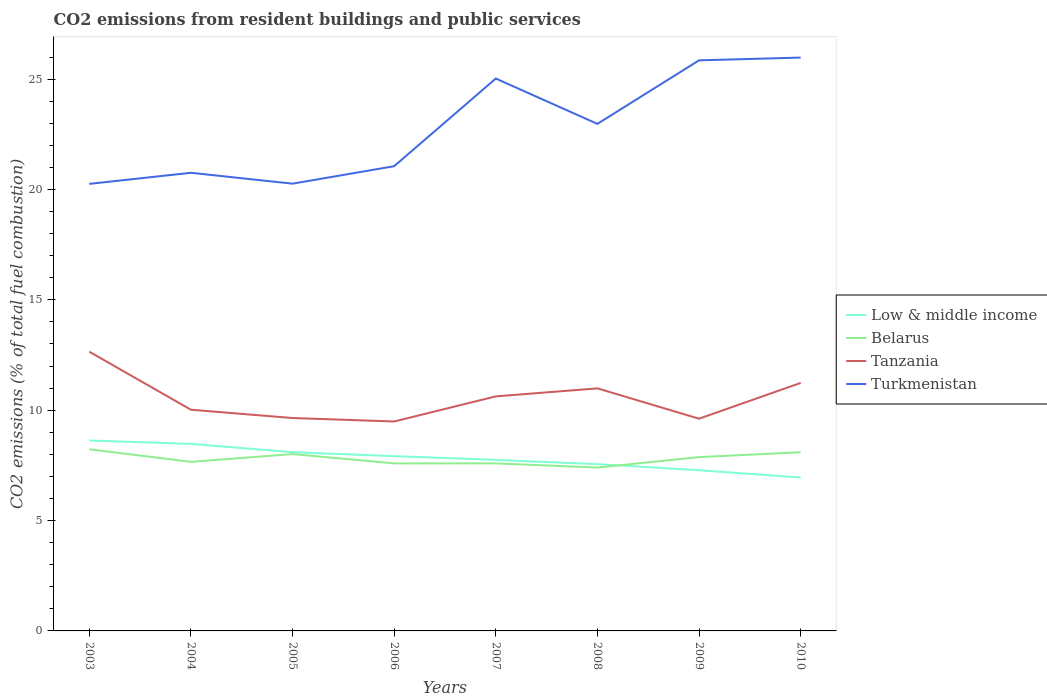Across all years, what is the maximum total CO2 emitted in Tanzania?
Offer a terse response. 9.49. In which year was the total CO2 emitted in Tanzania maximum?
Keep it short and to the point. 2006. What is the total total CO2 emitted in Low & middle income in the graph?
Ensure brevity in your answer.  0.54. What is the difference between the highest and the second highest total CO2 emitted in Low & middle income?
Provide a succinct answer. 1.68. What is the difference between the highest and the lowest total CO2 emitted in Belarus?
Provide a short and direct response. 4. What is the difference between two consecutive major ticks on the Y-axis?
Your answer should be very brief. 5. Are the values on the major ticks of Y-axis written in scientific E-notation?
Give a very brief answer. No. What is the title of the graph?
Keep it short and to the point. CO2 emissions from resident buildings and public services. What is the label or title of the X-axis?
Your answer should be very brief. Years. What is the label or title of the Y-axis?
Make the answer very short. CO2 emissions (% of total fuel combustion). What is the CO2 emissions (% of total fuel combustion) in Low & middle income in 2003?
Provide a short and direct response. 8.63. What is the CO2 emissions (% of total fuel combustion) of Belarus in 2003?
Provide a succinct answer. 8.23. What is the CO2 emissions (% of total fuel combustion) in Tanzania in 2003?
Your response must be concise. 12.65. What is the CO2 emissions (% of total fuel combustion) of Turkmenistan in 2003?
Ensure brevity in your answer.  20.25. What is the CO2 emissions (% of total fuel combustion) in Low & middle income in 2004?
Provide a short and direct response. 8.47. What is the CO2 emissions (% of total fuel combustion) in Belarus in 2004?
Ensure brevity in your answer.  7.66. What is the CO2 emissions (% of total fuel combustion) in Tanzania in 2004?
Your answer should be very brief. 10.02. What is the CO2 emissions (% of total fuel combustion) in Turkmenistan in 2004?
Keep it short and to the point. 20.76. What is the CO2 emissions (% of total fuel combustion) of Low & middle income in 2005?
Your response must be concise. 8.1. What is the CO2 emissions (% of total fuel combustion) in Belarus in 2005?
Provide a short and direct response. 8.01. What is the CO2 emissions (% of total fuel combustion) of Tanzania in 2005?
Your response must be concise. 9.65. What is the CO2 emissions (% of total fuel combustion) in Turkmenistan in 2005?
Provide a succinct answer. 20.26. What is the CO2 emissions (% of total fuel combustion) in Low & middle income in 2006?
Your response must be concise. 7.92. What is the CO2 emissions (% of total fuel combustion) of Belarus in 2006?
Keep it short and to the point. 7.59. What is the CO2 emissions (% of total fuel combustion) of Tanzania in 2006?
Offer a very short reply. 9.49. What is the CO2 emissions (% of total fuel combustion) of Turkmenistan in 2006?
Make the answer very short. 21.05. What is the CO2 emissions (% of total fuel combustion) of Low & middle income in 2007?
Offer a terse response. 7.75. What is the CO2 emissions (% of total fuel combustion) in Belarus in 2007?
Your answer should be very brief. 7.59. What is the CO2 emissions (% of total fuel combustion) of Tanzania in 2007?
Your answer should be compact. 10.63. What is the CO2 emissions (% of total fuel combustion) in Turkmenistan in 2007?
Your answer should be compact. 25.03. What is the CO2 emissions (% of total fuel combustion) of Low & middle income in 2008?
Your response must be concise. 7.56. What is the CO2 emissions (% of total fuel combustion) in Belarus in 2008?
Provide a succinct answer. 7.4. What is the CO2 emissions (% of total fuel combustion) of Tanzania in 2008?
Your answer should be very brief. 10.99. What is the CO2 emissions (% of total fuel combustion) of Turkmenistan in 2008?
Offer a very short reply. 22.97. What is the CO2 emissions (% of total fuel combustion) in Low & middle income in 2009?
Offer a very short reply. 7.28. What is the CO2 emissions (% of total fuel combustion) of Belarus in 2009?
Provide a short and direct response. 7.88. What is the CO2 emissions (% of total fuel combustion) in Tanzania in 2009?
Your response must be concise. 9.62. What is the CO2 emissions (% of total fuel combustion) of Turkmenistan in 2009?
Keep it short and to the point. 25.85. What is the CO2 emissions (% of total fuel combustion) of Low & middle income in 2010?
Give a very brief answer. 6.95. What is the CO2 emissions (% of total fuel combustion) of Belarus in 2010?
Offer a very short reply. 8.1. What is the CO2 emissions (% of total fuel combustion) of Tanzania in 2010?
Your answer should be compact. 11.24. What is the CO2 emissions (% of total fuel combustion) of Turkmenistan in 2010?
Keep it short and to the point. 25.98. Across all years, what is the maximum CO2 emissions (% of total fuel combustion) of Low & middle income?
Your answer should be very brief. 8.63. Across all years, what is the maximum CO2 emissions (% of total fuel combustion) in Belarus?
Ensure brevity in your answer.  8.23. Across all years, what is the maximum CO2 emissions (% of total fuel combustion) in Tanzania?
Provide a short and direct response. 12.65. Across all years, what is the maximum CO2 emissions (% of total fuel combustion) in Turkmenistan?
Ensure brevity in your answer.  25.98. Across all years, what is the minimum CO2 emissions (% of total fuel combustion) of Low & middle income?
Provide a succinct answer. 6.95. Across all years, what is the minimum CO2 emissions (% of total fuel combustion) of Belarus?
Provide a succinct answer. 7.4. Across all years, what is the minimum CO2 emissions (% of total fuel combustion) of Tanzania?
Offer a very short reply. 9.49. Across all years, what is the minimum CO2 emissions (% of total fuel combustion) of Turkmenistan?
Your response must be concise. 20.25. What is the total CO2 emissions (% of total fuel combustion) in Low & middle income in the graph?
Provide a short and direct response. 62.65. What is the total CO2 emissions (% of total fuel combustion) of Belarus in the graph?
Your answer should be very brief. 62.46. What is the total CO2 emissions (% of total fuel combustion) of Tanzania in the graph?
Provide a short and direct response. 84.27. What is the total CO2 emissions (% of total fuel combustion) in Turkmenistan in the graph?
Offer a very short reply. 182.16. What is the difference between the CO2 emissions (% of total fuel combustion) in Low & middle income in 2003 and that in 2004?
Make the answer very short. 0.15. What is the difference between the CO2 emissions (% of total fuel combustion) of Belarus in 2003 and that in 2004?
Offer a terse response. 0.57. What is the difference between the CO2 emissions (% of total fuel combustion) of Tanzania in 2003 and that in 2004?
Keep it short and to the point. 2.63. What is the difference between the CO2 emissions (% of total fuel combustion) in Turkmenistan in 2003 and that in 2004?
Keep it short and to the point. -0.5. What is the difference between the CO2 emissions (% of total fuel combustion) in Low & middle income in 2003 and that in 2005?
Your answer should be very brief. 0.53. What is the difference between the CO2 emissions (% of total fuel combustion) of Belarus in 2003 and that in 2005?
Offer a very short reply. 0.22. What is the difference between the CO2 emissions (% of total fuel combustion) of Tanzania in 2003 and that in 2005?
Offer a terse response. 3. What is the difference between the CO2 emissions (% of total fuel combustion) of Turkmenistan in 2003 and that in 2005?
Offer a terse response. -0.01. What is the difference between the CO2 emissions (% of total fuel combustion) of Low & middle income in 2003 and that in 2006?
Keep it short and to the point. 0.71. What is the difference between the CO2 emissions (% of total fuel combustion) of Belarus in 2003 and that in 2006?
Ensure brevity in your answer.  0.64. What is the difference between the CO2 emissions (% of total fuel combustion) in Tanzania in 2003 and that in 2006?
Provide a short and direct response. 3.16. What is the difference between the CO2 emissions (% of total fuel combustion) in Turkmenistan in 2003 and that in 2006?
Your response must be concise. -0.8. What is the difference between the CO2 emissions (% of total fuel combustion) of Low & middle income in 2003 and that in 2007?
Make the answer very short. 0.88. What is the difference between the CO2 emissions (% of total fuel combustion) of Belarus in 2003 and that in 2007?
Your response must be concise. 0.64. What is the difference between the CO2 emissions (% of total fuel combustion) of Tanzania in 2003 and that in 2007?
Ensure brevity in your answer.  2.02. What is the difference between the CO2 emissions (% of total fuel combustion) in Turkmenistan in 2003 and that in 2007?
Keep it short and to the point. -4.77. What is the difference between the CO2 emissions (% of total fuel combustion) in Low & middle income in 2003 and that in 2008?
Your answer should be compact. 1.07. What is the difference between the CO2 emissions (% of total fuel combustion) in Belarus in 2003 and that in 2008?
Provide a succinct answer. 0.83. What is the difference between the CO2 emissions (% of total fuel combustion) in Tanzania in 2003 and that in 2008?
Keep it short and to the point. 1.66. What is the difference between the CO2 emissions (% of total fuel combustion) of Turkmenistan in 2003 and that in 2008?
Your response must be concise. -2.72. What is the difference between the CO2 emissions (% of total fuel combustion) in Low & middle income in 2003 and that in 2009?
Provide a short and direct response. 1.35. What is the difference between the CO2 emissions (% of total fuel combustion) of Belarus in 2003 and that in 2009?
Your response must be concise. 0.35. What is the difference between the CO2 emissions (% of total fuel combustion) in Tanzania in 2003 and that in 2009?
Offer a terse response. 3.04. What is the difference between the CO2 emissions (% of total fuel combustion) of Turkmenistan in 2003 and that in 2009?
Give a very brief answer. -5.6. What is the difference between the CO2 emissions (% of total fuel combustion) in Low & middle income in 2003 and that in 2010?
Offer a very short reply. 1.68. What is the difference between the CO2 emissions (% of total fuel combustion) in Belarus in 2003 and that in 2010?
Offer a terse response. 0.13. What is the difference between the CO2 emissions (% of total fuel combustion) in Tanzania in 2003 and that in 2010?
Give a very brief answer. 1.41. What is the difference between the CO2 emissions (% of total fuel combustion) in Turkmenistan in 2003 and that in 2010?
Give a very brief answer. -5.72. What is the difference between the CO2 emissions (% of total fuel combustion) in Low & middle income in 2004 and that in 2005?
Give a very brief answer. 0.38. What is the difference between the CO2 emissions (% of total fuel combustion) of Belarus in 2004 and that in 2005?
Ensure brevity in your answer.  -0.35. What is the difference between the CO2 emissions (% of total fuel combustion) of Tanzania in 2004 and that in 2005?
Ensure brevity in your answer.  0.38. What is the difference between the CO2 emissions (% of total fuel combustion) in Turkmenistan in 2004 and that in 2005?
Give a very brief answer. 0.49. What is the difference between the CO2 emissions (% of total fuel combustion) in Low & middle income in 2004 and that in 2006?
Make the answer very short. 0.56. What is the difference between the CO2 emissions (% of total fuel combustion) of Belarus in 2004 and that in 2006?
Offer a terse response. 0.07. What is the difference between the CO2 emissions (% of total fuel combustion) in Tanzania in 2004 and that in 2006?
Give a very brief answer. 0.53. What is the difference between the CO2 emissions (% of total fuel combustion) in Turkmenistan in 2004 and that in 2006?
Make the answer very short. -0.3. What is the difference between the CO2 emissions (% of total fuel combustion) in Low & middle income in 2004 and that in 2007?
Keep it short and to the point. 0.72. What is the difference between the CO2 emissions (% of total fuel combustion) in Belarus in 2004 and that in 2007?
Give a very brief answer. 0.07. What is the difference between the CO2 emissions (% of total fuel combustion) in Tanzania in 2004 and that in 2007?
Your answer should be very brief. -0.6. What is the difference between the CO2 emissions (% of total fuel combustion) of Turkmenistan in 2004 and that in 2007?
Provide a succinct answer. -4.27. What is the difference between the CO2 emissions (% of total fuel combustion) in Low & middle income in 2004 and that in 2008?
Offer a very short reply. 0.92. What is the difference between the CO2 emissions (% of total fuel combustion) of Belarus in 2004 and that in 2008?
Offer a very short reply. 0.26. What is the difference between the CO2 emissions (% of total fuel combustion) in Tanzania in 2004 and that in 2008?
Offer a terse response. -0.97. What is the difference between the CO2 emissions (% of total fuel combustion) of Turkmenistan in 2004 and that in 2008?
Offer a terse response. -2.22. What is the difference between the CO2 emissions (% of total fuel combustion) in Low & middle income in 2004 and that in 2009?
Your response must be concise. 1.19. What is the difference between the CO2 emissions (% of total fuel combustion) of Belarus in 2004 and that in 2009?
Keep it short and to the point. -0.21. What is the difference between the CO2 emissions (% of total fuel combustion) in Tanzania in 2004 and that in 2009?
Provide a succinct answer. 0.41. What is the difference between the CO2 emissions (% of total fuel combustion) in Turkmenistan in 2004 and that in 2009?
Provide a short and direct response. -5.09. What is the difference between the CO2 emissions (% of total fuel combustion) of Low & middle income in 2004 and that in 2010?
Your answer should be compact. 1.52. What is the difference between the CO2 emissions (% of total fuel combustion) in Belarus in 2004 and that in 2010?
Provide a short and direct response. -0.44. What is the difference between the CO2 emissions (% of total fuel combustion) of Tanzania in 2004 and that in 2010?
Offer a very short reply. -1.21. What is the difference between the CO2 emissions (% of total fuel combustion) in Turkmenistan in 2004 and that in 2010?
Your response must be concise. -5.22. What is the difference between the CO2 emissions (% of total fuel combustion) of Low & middle income in 2005 and that in 2006?
Your response must be concise. 0.18. What is the difference between the CO2 emissions (% of total fuel combustion) in Belarus in 2005 and that in 2006?
Your answer should be very brief. 0.42. What is the difference between the CO2 emissions (% of total fuel combustion) in Tanzania in 2005 and that in 2006?
Keep it short and to the point. 0.16. What is the difference between the CO2 emissions (% of total fuel combustion) in Turkmenistan in 2005 and that in 2006?
Make the answer very short. -0.79. What is the difference between the CO2 emissions (% of total fuel combustion) in Low & middle income in 2005 and that in 2007?
Offer a terse response. 0.35. What is the difference between the CO2 emissions (% of total fuel combustion) of Belarus in 2005 and that in 2007?
Your answer should be compact. 0.42. What is the difference between the CO2 emissions (% of total fuel combustion) in Tanzania in 2005 and that in 2007?
Keep it short and to the point. -0.98. What is the difference between the CO2 emissions (% of total fuel combustion) in Turkmenistan in 2005 and that in 2007?
Your answer should be compact. -4.76. What is the difference between the CO2 emissions (% of total fuel combustion) in Low & middle income in 2005 and that in 2008?
Provide a succinct answer. 0.54. What is the difference between the CO2 emissions (% of total fuel combustion) of Belarus in 2005 and that in 2008?
Keep it short and to the point. 0.61. What is the difference between the CO2 emissions (% of total fuel combustion) of Tanzania in 2005 and that in 2008?
Provide a succinct answer. -1.34. What is the difference between the CO2 emissions (% of total fuel combustion) of Turkmenistan in 2005 and that in 2008?
Keep it short and to the point. -2.71. What is the difference between the CO2 emissions (% of total fuel combustion) in Low & middle income in 2005 and that in 2009?
Keep it short and to the point. 0.82. What is the difference between the CO2 emissions (% of total fuel combustion) in Belarus in 2005 and that in 2009?
Give a very brief answer. 0.14. What is the difference between the CO2 emissions (% of total fuel combustion) of Tanzania in 2005 and that in 2009?
Offer a terse response. 0.03. What is the difference between the CO2 emissions (% of total fuel combustion) of Turkmenistan in 2005 and that in 2009?
Give a very brief answer. -5.59. What is the difference between the CO2 emissions (% of total fuel combustion) in Low & middle income in 2005 and that in 2010?
Make the answer very short. 1.15. What is the difference between the CO2 emissions (% of total fuel combustion) of Belarus in 2005 and that in 2010?
Provide a short and direct response. -0.08. What is the difference between the CO2 emissions (% of total fuel combustion) in Tanzania in 2005 and that in 2010?
Your response must be concise. -1.59. What is the difference between the CO2 emissions (% of total fuel combustion) of Turkmenistan in 2005 and that in 2010?
Your answer should be compact. -5.71. What is the difference between the CO2 emissions (% of total fuel combustion) in Low & middle income in 2006 and that in 2007?
Give a very brief answer. 0.17. What is the difference between the CO2 emissions (% of total fuel combustion) of Belarus in 2006 and that in 2007?
Give a very brief answer. -0. What is the difference between the CO2 emissions (% of total fuel combustion) in Tanzania in 2006 and that in 2007?
Ensure brevity in your answer.  -1.14. What is the difference between the CO2 emissions (% of total fuel combustion) of Turkmenistan in 2006 and that in 2007?
Your answer should be compact. -3.97. What is the difference between the CO2 emissions (% of total fuel combustion) in Low & middle income in 2006 and that in 2008?
Offer a very short reply. 0.36. What is the difference between the CO2 emissions (% of total fuel combustion) of Belarus in 2006 and that in 2008?
Provide a succinct answer. 0.19. What is the difference between the CO2 emissions (% of total fuel combustion) in Turkmenistan in 2006 and that in 2008?
Your answer should be compact. -1.92. What is the difference between the CO2 emissions (% of total fuel combustion) of Low & middle income in 2006 and that in 2009?
Your answer should be very brief. 0.64. What is the difference between the CO2 emissions (% of total fuel combustion) in Belarus in 2006 and that in 2009?
Offer a very short reply. -0.28. What is the difference between the CO2 emissions (% of total fuel combustion) in Tanzania in 2006 and that in 2009?
Your answer should be compact. -0.13. What is the difference between the CO2 emissions (% of total fuel combustion) of Turkmenistan in 2006 and that in 2009?
Offer a very short reply. -4.8. What is the difference between the CO2 emissions (% of total fuel combustion) of Low & middle income in 2006 and that in 2010?
Make the answer very short. 0.97. What is the difference between the CO2 emissions (% of total fuel combustion) in Belarus in 2006 and that in 2010?
Offer a very short reply. -0.51. What is the difference between the CO2 emissions (% of total fuel combustion) in Tanzania in 2006 and that in 2010?
Your response must be concise. -1.75. What is the difference between the CO2 emissions (% of total fuel combustion) of Turkmenistan in 2006 and that in 2010?
Your response must be concise. -4.92. What is the difference between the CO2 emissions (% of total fuel combustion) in Low & middle income in 2007 and that in 2008?
Make the answer very short. 0.2. What is the difference between the CO2 emissions (% of total fuel combustion) in Belarus in 2007 and that in 2008?
Ensure brevity in your answer.  0.19. What is the difference between the CO2 emissions (% of total fuel combustion) in Tanzania in 2007 and that in 2008?
Your answer should be very brief. -0.36. What is the difference between the CO2 emissions (% of total fuel combustion) in Turkmenistan in 2007 and that in 2008?
Offer a terse response. 2.05. What is the difference between the CO2 emissions (% of total fuel combustion) in Low & middle income in 2007 and that in 2009?
Provide a succinct answer. 0.47. What is the difference between the CO2 emissions (% of total fuel combustion) in Belarus in 2007 and that in 2009?
Your answer should be compact. -0.28. What is the difference between the CO2 emissions (% of total fuel combustion) in Tanzania in 2007 and that in 2009?
Ensure brevity in your answer.  1.01. What is the difference between the CO2 emissions (% of total fuel combustion) in Turkmenistan in 2007 and that in 2009?
Keep it short and to the point. -0.82. What is the difference between the CO2 emissions (% of total fuel combustion) in Low & middle income in 2007 and that in 2010?
Your answer should be compact. 0.8. What is the difference between the CO2 emissions (% of total fuel combustion) of Belarus in 2007 and that in 2010?
Make the answer very short. -0.51. What is the difference between the CO2 emissions (% of total fuel combustion) in Tanzania in 2007 and that in 2010?
Offer a very short reply. -0.61. What is the difference between the CO2 emissions (% of total fuel combustion) of Turkmenistan in 2007 and that in 2010?
Keep it short and to the point. -0.95. What is the difference between the CO2 emissions (% of total fuel combustion) of Low & middle income in 2008 and that in 2009?
Your answer should be compact. 0.28. What is the difference between the CO2 emissions (% of total fuel combustion) of Belarus in 2008 and that in 2009?
Offer a terse response. -0.47. What is the difference between the CO2 emissions (% of total fuel combustion) in Tanzania in 2008 and that in 2009?
Your response must be concise. 1.37. What is the difference between the CO2 emissions (% of total fuel combustion) in Turkmenistan in 2008 and that in 2009?
Offer a terse response. -2.88. What is the difference between the CO2 emissions (% of total fuel combustion) in Low & middle income in 2008 and that in 2010?
Provide a succinct answer. 0.6. What is the difference between the CO2 emissions (% of total fuel combustion) of Belarus in 2008 and that in 2010?
Provide a succinct answer. -0.69. What is the difference between the CO2 emissions (% of total fuel combustion) in Tanzania in 2008 and that in 2010?
Keep it short and to the point. -0.25. What is the difference between the CO2 emissions (% of total fuel combustion) in Turkmenistan in 2008 and that in 2010?
Offer a very short reply. -3. What is the difference between the CO2 emissions (% of total fuel combustion) in Low & middle income in 2009 and that in 2010?
Make the answer very short. 0.33. What is the difference between the CO2 emissions (% of total fuel combustion) of Belarus in 2009 and that in 2010?
Provide a short and direct response. -0.22. What is the difference between the CO2 emissions (% of total fuel combustion) of Tanzania in 2009 and that in 2010?
Ensure brevity in your answer.  -1.62. What is the difference between the CO2 emissions (% of total fuel combustion) in Turkmenistan in 2009 and that in 2010?
Your answer should be compact. -0.13. What is the difference between the CO2 emissions (% of total fuel combustion) of Low & middle income in 2003 and the CO2 emissions (% of total fuel combustion) of Belarus in 2004?
Keep it short and to the point. 0.97. What is the difference between the CO2 emissions (% of total fuel combustion) in Low & middle income in 2003 and the CO2 emissions (% of total fuel combustion) in Tanzania in 2004?
Ensure brevity in your answer.  -1.39. What is the difference between the CO2 emissions (% of total fuel combustion) in Low & middle income in 2003 and the CO2 emissions (% of total fuel combustion) in Turkmenistan in 2004?
Make the answer very short. -12.13. What is the difference between the CO2 emissions (% of total fuel combustion) of Belarus in 2003 and the CO2 emissions (% of total fuel combustion) of Tanzania in 2004?
Your answer should be compact. -1.79. What is the difference between the CO2 emissions (% of total fuel combustion) of Belarus in 2003 and the CO2 emissions (% of total fuel combustion) of Turkmenistan in 2004?
Ensure brevity in your answer.  -12.53. What is the difference between the CO2 emissions (% of total fuel combustion) of Tanzania in 2003 and the CO2 emissions (% of total fuel combustion) of Turkmenistan in 2004?
Your response must be concise. -8.11. What is the difference between the CO2 emissions (% of total fuel combustion) in Low & middle income in 2003 and the CO2 emissions (% of total fuel combustion) in Belarus in 2005?
Provide a short and direct response. 0.62. What is the difference between the CO2 emissions (% of total fuel combustion) in Low & middle income in 2003 and the CO2 emissions (% of total fuel combustion) in Tanzania in 2005?
Your answer should be compact. -1.02. What is the difference between the CO2 emissions (% of total fuel combustion) of Low & middle income in 2003 and the CO2 emissions (% of total fuel combustion) of Turkmenistan in 2005?
Your answer should be compact. -11.64. What is the difference between the CO2 emissions (% of total fuel combustion) of Belarus in 2003 and the CO2 emissions (% of total fuel combustion) of Tanzania in 2005?
Your answer should be very brief. -1.42. What is the difference between the CO2 emissions (% of total fuel combustion) in Belarus in 2003 and the CO2 emissions (% of total fuel combustion) in Turkmenistan in 2005?
Provide a succinct answer. -12.03. What is the difference between the CO2 emissions (% of total fuel combustion) in Tanzania in 2003 and the CO2 emissions (% of total fuel combustion) in Turkmenistan in 2005?
Make the answer very short. -7.61. What is the difference between the CO2 emissions (% of total fuel combustion) in Low & middle income in 2003 and the CO2 emissions (% of total fuel combustion) in Belarus in 2006?
Give a very brief answer. 1.04. What is the difference between the CO2 emissions (% of total fuel combustion) of Low & middle income in 2003 and the CO2 emissions (% of total fuel combustion) of Tanzania in 2006?
Your answer should be very brief. -0.86. What is the difference between the CO2 emissions (% of total fuel combustion) in Low & middle income in 2003 and the CO2 emissions (% of total fuel combustion) in Turkmenistan in 2006?
Your response must be concise. -12.43. What is the difference between the CO2 emissions (% of total fuel combustion) in Belarus in 2003 and the CO2 emissions (% of total fuel combustion) in Tanzania in 2006?
Provide a short and direct response. -1.26. What is the difference between the CO2 emissions (% of total fuel combustion) in Belarus in 2003 and the CO2 emissions (% of total fuel combustion) in Turkmenistan in 2006?
Your response must be concise. -12.82. What is the difference between the CO2 emissions (% of total fuel combustion) of Tanzania in 2003 and the CO2 emissions (% of total fuel combustion) of Turkmenistan in 2006?
Offer a very short reply. -8.4. What is the difference between the CO2 emissions (% of total fuel combustion) of Low & middle income in 2003 and the CO2 emissions (% of total fuel combustion) of Belarus in 2007?
Provide a succinct answer. 1.04. What is the difference between the CO2 emissions (% of total fuel combustion) of Low & middle income in 2003 and the CO2 emissions (% of total fuel combustion) of Tanzania in 2007?
Keep it short and to the point. -2. What is the difference between the CO2 emissions (% of total fuel combustion) in Low & middle income in 2003 and the CO2 emissions (% of total fuel combustion) in Turkmenistan in 2007?
Your answer should be compact. -16.4. What is the difference between the CO2 emissions (% of total fuel combustion) in Belarus in 2003 and the CO2 emissions (% of total fuel combustion) in Tanzania in 2007?
Your response must be concise. -2.4. What is the difference between the CO2 emissions (% of total fuel combustion) of Belarus in 2003 and the CO2 emissions (% of total fuel combustion) of Turkmenistan in 2007?
Provide a succinct answer. -16.8. What is the difference between the CO2 emissions (% of total fuel combustion) of Tanzania in 2003 and the CO2 emissions (% of total fuel combustion) of Turkmenistan in 2007?
Your answer should be very brief. -12.38. What is the difference between the CO2 emissions (% of total fuel combustion) in Low & middle income in 2003 and the CO2 emissions (% of total fuel combustion) in Belarus in 2008?
Give a very brief answer. 1.23. What is the difference between the CO2 emissions (% of total fuel combustion) in Low & middle income in 2003 and the CO2 emissions (% of total fuel combustion) in Tanzania in 2008?
Provide a short and direct response. -2.36. What is the difference between the CO2 emissions (% of total fuel combustion) of Low & middle income in 2003 and the CO2 emissions (% of total fuel combustion) of Turkmenistan in 2008?
Provide a short and direct response. -14.34. What is the difference between the CO2 emissions (% of total fuel combustion) in Belarus in 2003 and the CO2 emissions (% of total fuel combustion) in Tanzania in 2008?
Offer a terse response. -2.76. What is the difference between the CO2 emissions (% of total fuel combustion) in Belarus in 2003 and the CO2 emissions (% of total fuel combustion) in Turkmenistan in 2008?
Give a very brief answer. -14.74. What is the difference between the CO2 emissions (% of total fuel combustion) in Tanzania in 2003 and the CO2 emissions (% of total fuel combustion) in Turkmenistan in 2008?
Provide a short and direct response. -10.32. What is the difference between the CO2 emissions (% of total fuel combustion) in Low & middle income in 2003 and the CO2 emissions (% of total fuel combustion) in Belarus in 2009?
Make the answer very short. 0.75. What is the difference between the CO2 emissions (% of total fuel combustion) in Low & middle income in 2003 and the CO2 emissions (% of total fuel combustion) in Tanzania in 2009?
Your response must be concise. -0.99. What is the difference between the CO2 emissions (% of total fuel combustion) of Low & middle income in 2003 and the CO2 emissions (% of total fuel combustion) of Turkmenistan in 2009?
Provide a short and direct response. -17.22. What is the difference between the CO2 emissions (% of total fuel combustion) in Belarus in 2003 and the CO2 emissions (% of total fuel combustion) in Tanzania in 2009?
Make the answer very short. -1.39. What is the difference between the CO2 emissions (% of total fuel combustion) in Belarus in 2003 and the CO2 emissions (% of total fuel combustion) in Turkmenistan in 2009?
Provide a short and direct response. -17.62. What is the difference between the CO2 emissions (% of total fuel combustion) of Tanzania in 2003 and the CO2 emissions (% of total fuel combustion) of Turkmenistan in 2009?
Provide a short and direct response. -13.2. What is the difference between the CO2 emissions (% of total fuel combustion) of Low & middle income in 2003 and the CO2 emissions (% of total fuel combustion) of Belarus in 2010?
Ensure brevity in your answer.  0.53. What is the difference between the CO2 emissions (% of total fuel combustion) of Low & middle income in 2003 and the CO2 emissions (% of total fuel combustion) of Tanzania in 2010?
Your answer should be very brief. -2.61. What is the difference between the CO2 emissions (% of total fuel combustion) of Low & middle income in 2003 and the CO2 emissions (% of total fuel combustion) of Turkmenistan in 2010?
Offer a very short reply. -17.35. What is the difference between the CO2 emissions (% of total fuel combustion) of Belarus in 2003 and the CO2 emissions (% of total fuel combustion) of Tanzania in 2010?
Provide a short and direct response. -3.01. What is the difference between the CO2 emissions (% of total fuel combustion) in Belarus in 2003 and the CO2 emissions (% of total fuel combustion) in Turkmenistan in 2010?
Provide a short and direct response. -17.75. What is the difference between the CO2 emissions (% of total fuel combustion) of Tanzania in 2003 and the CO2 emissions (% of total fuel combustion) of Turkmenistan in 2010?
Your response must be concise. -13.33. What is the difference between the CO2 emissions (% of total fuel combustion) in Low & middle income in 2004 and the CO2 emissions (% of total fuel combustion) in Belarus in 2005?
Make the answer very short. 0.46. What is the difference between the CO2 emissions (% of total fuel combustion) in Low & middle income in 2004 and the CO2 emissions (% of total fuel combustion) in Tanzania in 2005?
Offer a very short reply. -1.17. What is the difference between the CO2 emissions (% of total fuel combustion) in Low & middle income in 2004 and the CO2 emissions (% of total fuel combustion) in Turkmenistan in 2005?
Give a very brief answer. -11.79. What is the difference between the CO2 emissions (% of total fuel combustion) of Belarus in 2004 and the CO2 emissions (% of total fuel combustion) of Tanzania in 2005?
Your answer should be compact. -1.99. What is the difference between the CO2 emissions (% of total fuel combustion) of Belarus in 2004 and the CO2 emissions (% of total fuel combustion) of Turkmenistan in 2005?
Your response must be concise. -12.6. What is the difference between the CO2 emissions (% of total fuel combustion) in Tanzania in 2004 and the CO2 emissions (% of total fuel combustion) in Turkmenistan in 2005?
Give a very brief answer. -10.24. What is the difference between the CO2 emissions (% of total fuel combustion) in Low & middle income in 2004 and the CO2 emissions (% of total fuel combustion) in Belarus in 2006?
Offer a terse response. 0.88. What is the difference between the CO2 emissions (% of total fuel combustion) of Low & middle income in 2004 and the CO2 emissions (% of total fuel combustion) of Tanzania in 2006?
Your answer should be very brief. -1.02. What is the difference between the CO2 emissions (% of total fuel combustion) in Low & middle income in 2004 and the CO2 emissions (% of total fuel combustion) in Turkmenistan in 2006?
Provide a short and direct response. -12.58. What is the difference between the CO2 emissions (% of total fuel combustion) in Belarus in 2004 and the CO2 emissions (% of total fuel combustion) in Tanzania in 2006?
Make the answer very short. -1.83. What is the difference between the CO2 emissions (% of total fuel combustion) in Belarus in 2004 and the CO2 emissions (% of total fuel combustion) in Turkmenistan in 2006?
Make the answer very short. -13.39. What is the difference between the CO2 emissions (% of total fuel combustion) of Tanzania in 2004 and the CO2 emissions (% of total fuel combustion) of Turkmenistan in 2006?
Your answer should be very brief. -11.03. What is the difference between the CO2 emissions (% of total fuel combustion) in Low & middle income in 2004 and the CO2 emissions (% of total fuel combustion) in Belarus in 2007?
Provide a succinct answer. 0.88. What is the difference between the CO2 emissions (% of total fuel combustion) in Low & middle income in 2004 and the CO2 emissions (% of total fuel combustion) in Tanzania in 2007?
Your answer should be very brief. -2.15. What is the difference between the CO2 emissions (% of total fuel combustion) of Low & middle income in 2004 and the CO2 emissions (% of total fuel combustion) of Turkmenistan in 2007?
Make the answer very short. -16.55. What is the difference between the CO2 emissions (% of total fuel combustion) of Belarus in 2004 and the CO2 emissions (% of total fuel combustion) of Tanzania in 2007?
Provide a short and direct response. -2.97. What is the difference between the CO2 emissions (% of total fuel combustion) of Belarus in 2004 and the CO2 emissions (% of total fuel combustion) of Turkmenistan in 2007?
Ensure brevity in your answer.  -17.37. What is the difference between the CO2 emissions (% of total fuel combustion) in Tanzania in 2004 and the CO2 emissions (% of total fuel combustion) in Turkmenistan in 2007?
Offer a very short reply. -15.01. What is the difference between the CO2 emissions (% of total fuel combustion) in Low & middle income in 2004 and the CO2 emissions (% of total fuel combustion) in Belarus in 2008?
Offer a terse response. 1.07. What is the difference between the CO2 emissions (% of total fuel combustion) in Low & middle income in 2004 and the CO2 emissions (% of total fuel combustion) in Tanzania in 2008?
Your answer should be compact. -2.52. What is the difference between the CO2 emissions (% of total fuel combustion) in Low & middle income in 2004 and the CO2 emissions (% of total fuel combustion) in Turkmenistan in 2008?
Keep it short and to the point. -14.5. What is the difference between the CO2 emissions (% of total fuel combustion) in Belarus in 2004 and the CO2 emissions (% of total fuel combustion) in Tanzania in 2008?
Your answer should be compact. -3.33. What is the difference between the CO2 emissions (% of total fuel combustion) in Belarus in 2004 and the CO2 emissions (% of total fuel combustion) in Turkmenistan in 2008?
Offer a terse response. -15.31. What is the difference between the CO2 emissions (% of total fuel combustion) in Tanzania in 2004 and the CO2 emissions (% of total fuel combustion) in Turkmenistan in 2008?
Your response must be concise. -12.95. What is the difference between the CO2 emissions (% of total fuel combustion) in Low & middle income in 2004 and the CO2 emissions (% of total fuel combustion) in Belarus in 2009?
Offer a very short reply. 0.6. What is the difference between the CO2 emissions (% of total fuel combustion) in Low & middle income in 2004 and the CO2 emissions (% of total fuel combustion) in Tanzania in 2009?
Your response must be concise. -1.14. What is the difference between the CO2 emissions (% of total fuel combustion) in Low & middle income in 2004 and the CO2 emissions (% of total fuel combustion) in Turkmenistan in 2009?
Your answer should be very brief. -17.38. What is the difference between the CO2 emissions (% of total fuel combustion) in Belarus in 2004 and the CO2 emissions (% of total fuel combustion) in Tanzania in 2009?
Offer a terse response. -1.95. What is the difference between the CO2 emissions (% of total fuel combustion) of Belarus in 2004 and the CO2 emissions (% of total fuel combustion) of Turkmenistan in 2009?
Give a very brief answer. -18.19. What is the difference between the CO2 emissions (% of total fuel combustion) in Tanzania in 2004 and the CO2 emissions (% of total fuel combustion) in Turkmenistan in 2009?
Keep it short and to the point. -15.83. What is the difference between the CO2 emissions (% of total fuel combustion) of Low & middle income in 2004 and the CO2 emissions (% of total fuel combustion) of Belarus in 2010?
Keep it short and to the point. 0.38. What is the difference between the CO2 emissions (% of total fuel combustion) in Low & middle income in 2004 and the CO2 emissions (% of total fuel combustion) in Tanzania in 2010?
Provide a succinct answer. -2.76. What is the difference between the CO2 emissions (% of total fuel combustion) in Low & middle income in 2004 and the CO2 emissions (% of total fuel combustion) in Turkmenistan in 2010?
Provide a short and direct response. -17.5. What is the difference between the CO2 emissions (% of total fuel combustion) in Belarus in 2004 and the CO2 emissions (% of total fuel combustion) in Tanzania in 2010?
Your answer should be very brief. -3.58. What is the difference between the CO2 emissions (% of total fuel combustion) in Belarus in 2004 and the CO2 emissions (% of total fuel combustion) in Turkmenistan in 2010?
Make the answer very short. -18.32. What is the difference between the CO2 emissions (% of total fuel combustion) of Tanzania in 2004 and the CO2 emissions (% of total fuel combustion) of Turkmenistan in 2010?
Offer a very short reply. -15.95. What is the difference between the CO2 emissions (% of total fuel combustion) in Low & middle income in 2005 and the CO2 emissions (% of total fuel combustion) in Belarus in 2006?
Your answer should be very brief. 0.51. What is the difference between the CO2 emissions (% of total fuel combustion) of Low & middle income in 2005 and the CO2 emissions (% of total fuel combustion) of Tanzania in 2006?
Provide a short and direct response. -1.39. What is the difference between the CO2 emissions (% of total fuel combustion) of Low & middle income in 2005 and the CO2 emissions (% of total fuel combustion) of Turkmenistan in 2006?
Keep it short and to the point. -12.96. What is the difference between the CO2 emissions (% of total fuel combustion) of Belarus in 2005 and the CO2 emissions (% of total fuel combustion) of Tanzania in 2006?
Your answer should be very brief. -1.48. What is the difference between the CO2 emissions (% of total fuel combustion) of Belarus in 2005 and the CO2 emissions (% of total fuel combustion) of Turkmenistan in 2006?
Make the answer very short. -13.04. What is the difference between the CO2 emissions (% of total fuel combustion) in Tanzania in 2005 and the CO2 emissions (% of total fuel combustion) in Turkmenistan in 2006?
Offer a very short reply. -11.41. What is the difference between the CO2 emissions (% of total fuel combustion) of Low & middle income in 2005 and the CO2 emissions (% of total fuel combustion) of Belarus in 2007?
Your answer should be compact. 0.51. What is the difference between the CO2 emissions (% of total fuel combustion) in Low & middle income in 2005 and the CO2 emissions (% of total fuel combustion) in Tanzania in 2007?
Offer a terse response. -2.53. What is the difference between the CO2 emissions (% of total fuel combustion) in Low & middle income in 2005 and the CO2 emissions (% of total fuel combustion) in Turkmenistan in 2007?
Your answer should be very brief. -16.93. What is the difference between the CO2 emissions (% of total fuel combustion) of Belarus in 2005 and the CO2 emissions (% of total fuel combustion) of Tanzania in 2007?
Your answer should be very brief. -2.61. What is the difference between the CO2 emissions (% of total fuel combustion) in Belarus in 2005 and the CO2 emissions (% of total fuel combustion) in Turkmenistan in 2007?
Keep it short and to the point. -17.01. What is the difference between the CO2 emissions (% of total fuel combustion) of Tanzania in 2005 and the CO2 emissions (% of total fuel combustion) of Turkmenistan in 2007?
Give a very brief answer. -15.38. What is the difference between the CO2 emissions (% of total fuel combustion) in Low & middle income in 2005 and the CO2 emissions (% of total fuel combustion) in Belarus in 2008?
Keep it short and to the point. 0.7. What is the difference between the CO2 emissions (% of total fuel combustion) in Low & middle income in 2005 and the CO2 emissions (% of total fuel combustion) in Tanzania in 2008?
Make the answer very short. -2.89. What is the difference between the CO2 emissions (% of total fuel combustion) in Low & middle income in 2005 and the CO2 emissions (% of total fuel combustion) in Turkmenistan in 2008?
Ensure brevity in your answer.  -14.88. What is the difference between the CO2 emissions (% of total fuel combustion) in Belarus in 2005 and the CO2 emissions (% of total fuel combustion) in Tanzania in 2008?
Make the answer very short. -2.98. What is the difference between the CO2 emissions (% of total fuel combustion) in Belarus in 2005 and the CO2 emissions (% of total fuel combustion) in Turkmenistan in 2008?
Your answer should be compact. -14.96. What is the difference between the CO2 emissions (% of total fuel combustion) in Tanzania in 2005 and the CO2 emissions (% of total fuel combustion) in Turkmenistan in 2008?
Your response must be concise. -13.33. What is the difference between the CO2 emissions (% of total fuel combustion) of Low & middle income in 2005 and the CO2 emissions (% of total fuel combustion) of Belarus in 2009?
Provide a short and direct response. 0.22. What is the difference between the CO2 emissions (% of total fuel combustion) in Low & middle income in 2005 and the CO2 emissions (% of total fuel combustion) in Tanzania in 2009?
Provide a short and direct response. -1.52. What is the difference between the CO2 emissions (% of total fuel combustion) in Low & middle income in 2005 and the CO2 emissions (% of total fuel combustion) in Turkmenistan in 2009?
Provide a succinct answer. -17.75. What is the difference between the CO2 emissions (% of total fuel combustion) of Belarus in 2005 and the CO2 emissions (% of total fuel combustion) of Tanzania in 2009?
Your response must be concise. -1.6. What is the difference between the CO2 emissions (% of total fuel combustion) of Belarus in 2005 and the CO2 emissions (% of total fuel combustion) of Turkmenistan in 2009?
Provide a succinct answer. -17.84. What is the difference between the CO2 emissions (% of total fuel combustion) in Tanzania in 2005 and the CO2 emissions (% of total fuel combustion) in Turkmenistan in 2009?
Make the answer very short. -16.2. What is the difference between the CO2 emissions (% of total fuel combustion) of Low & middle income in 2005 and the CO2 emissions (% of total fuel combustion) of Belarus in 2010?
Give a very brief answer. 0. What is the difference between the CO2 emissions (% of total fuel combustion) of Low & middle income in 2005 and the CO2 emissions (% of total fuel combustion) of Tanzania in 2010?
Offer a very short reply. -3.14. What is the difference between the CO2 emissions (% of total fuel combustion) of Low & middle income in 2005 and the CO2 emissions (% of total fuel combustion) of Turkmenistan in 2010?
Your response must be concise. -17.88. What is the difference between the CO2 emissions (% of total fuel combustion) of Belarus in 2005 and the CO2 emissions (% of total fuel combustion) of Tanzania in 2010?
Make the answer very short. -3.22. What is the difference between the CO2 emissions (% of total fuel combustion) in Belarus in 2005 and the CO2 emissions (% of total fuel combustion) in Turkmenistan in 2010?
Offer a terse response. -17.96. What is the difference between the CO2 emissions (% of total fuel combustion) in Tanzania in 2005 and the CO2 emissions (% of total fuel combustion) in Turkmenistan in 2010?
Offer a terse response. -16.33. What is the difference between the CO2 emissions (% of total fuel combustion) of Low & middle income in 2006 and the CO2 emissions (% of total fuel combustion) of Belarus in 2007?
Ensure brevity in your answer.  0.33. What is the difference between the CO2 emissions (% of total fuel combustion) in Low & middle income in 2006 and the CO2 emissions (% of total fuel combustion) in Tanzania in 2007?
Give a very brief answer. -2.71. What is the difference between the CO2 emissions (% of total fuel combustion) of Low & middle income in 2006 and the CO2 emissions (% of total fuel combustion) of Turkmenistan in 2007?
Your answer should be very brief. -17.11. What is the difference between the CO2 emissions (% of total fuel combustion) of Belarus in 2006 and the CO2 emissions (% of total fuel combustion) of Tanzania in 2007?
Provide a short and direct response. -3.04. What is the difference between the CO2 emissions (% of total fuel combustion) in Belarus in 2006 and the CO2 emissions (% of total fuel combustion) in Turkmenistan in 2007?
Make the answer very short. -17.44. What is the difference between the CO2 emissions (% of total fuel combustion) of Tanzania in 2006 and the CO2 emissions (% of total fuel combustion) of Turkmenistan in 2007?
Your answer should be compact. -15.54. What is the difference between the CO2 emissions (% of total fuel combustion) in Low & middle income in 2006 and the CO2 emissions (% of total fuel combustion) in Belarus in 2008?
Ensure brevity in your answer.  0.52. What is the difference between the CO2 emissions (% of total fuel combustion) in Low & middle income in 2006 and the CO2 emissions (% of total fuel combustion) in Tanzania in 2008?
Make the answer very short. -3.07. What is the difference between the CO2 emissions (% of total fuel combustion) of Low & middle income in 2006 and the CO2 emissions (% of total fuel combustion) of Turkmenistan in 2008?
Offer a very short reply. -15.06. What is the difference between the CO2 emissions (% of total fuel combustion) in Belarus in 2006 and the CO2 emissions (% of total fuel combustion) in Tanzania in 2008?
Provide a succinct answer. -3.4. What is the difference between the CO2 emissions (% of total fuel combustion) in Belarus in 2006 and the CO2 emissions (% of total fuel combustion) in Turkmenistan in 2008?
Provide a succinct answer. -15.38. What is the difference between the CO2 emissions (% of total fuel combustion) of Tanzania in 2006 and the CO2 emissions (% of total fuel combustion) of Turkmenistan in 2008?
Offer a very short reply. -13.48. What is the difference between the CO2 emissions (% of total fuel combustion) in Low & middle income in 2006 and the CO2 emissions (% of total fuel combustion) in Belarus in 2009?
Keep it short and to the point. 0.04. What is the difference between the CO2 emissions (% of total fuel combustion) of Low & middle income in 2006 and the CO2 emissions (% of total fuel combustion) of Tanzania in 2009?
Keep it short and to the point. -1.7. What is the difference between the CO2 emissions (% of total fuel combustion) of Low & middle income in 2006 and the CO2 emissions (% of total fuel combustion) of Turkmenistan in 2009?
Your answer should be very brief. -17.93. What is the difference between the CO2 emissions (% of total fuel combustion) of Belarus in 2006 and the CO2 emissions (% of total fuel combustion) of Tanzania in 2009?
Offer a very short reply. -2.02. What is the difference between the CO2 emissions (% of total fuel combustion) of Belarus in 2006 and the CO2 emissions (% of total fuel combustion) of Turkmenistan in 2009?
Make the answer very short. -18.26. What is the difference between the CO2 emissions (% of total fuel combustion) of Tanzania in 2006 and the CO2 emissions (% of total fuel combustion) of Turkmenistan in 2009?
Provide a short and direct response. -16.36. What is the difference between the CO2 emissions (% of total fuel combustion) in Low & middle income in 2006 and the CO2 emissions (% of total fuel combustion) in Belarus in 2010?
Ensure brevity in your answer.  -0.18. What is the difference between the CO2 emissions (% of total fuel combustion) of Low & middle income in 2006 and the CO2 emissions (% of total fuel combustion) of Tanzania in 2010?
Your answer should be very brief. -3.32. What is the difference between the CO2 emissions (% of total fuel combustion) of Low & middle income in 2006 and the CO2 emissions (% of total fuel combustion) of Turkmenistan in 2010?
Ensure brevity in your answer.  -18.06. What is the difference between the CO2 emissions (% of total fuel combustion) in Belarus in 2006 and the CO2 emissions (% of total fuel combustion) in Tanzania in 2010?
Make the answer very short. -3.65. What is the difference between the CO2 emissions (% of total fuel combustion) of Belarus in 2006 and the CO2 emissions (% of total fuel combustion) of Turkmenistan in 2010?
Ensure brevity in your answer.  -18.39. What is the difference between the CO2 emissions (% of total fuel combustion) in Tanzania in 2006 and the CO2 emissions (% of total fuel combustion) in Turkmenistan in 2010?
Keep it short and to the point. -16.49. What is the difference between the CO2 emissions (% of total fuel combustion) of Low & middle income in 2007 and the CO2 emissions (% of total fuel combustion) of Belarus in 2008?
Your answer should be very brief. 0.35. What is the difference between the CO2 emissions (% of total fuel combustion) in Low & middle income in 2007 and the CO2 emissions (% of total fuel combustion) in Tanzania in 2008?
Your answer should be very brief. -3.24. What is the difference between the CO2 emissions (% of total fuel combustion) of Low & middle income in 2007 and the CO2 emissions (% of total fuel combustion) of Turkmenistan in 2008?
Provide a short and direct response. -15.22. What is the difference between the CO2 emissions (% of total fuel combustion) in Belarus in 2007 and the CO2 emissions (% of total fuel combustion) in Tanzania in 2008?
Ensure brevity in your answer.  -3.4. What is the difference between the CO2 emissions (% of total fuel combustion) of Belarus in 2007 and the CO2 emissions (% of total fuel combustion) of Turkmenistan in 2008?
Offer a terse response. -15.38. What is the difference between the CO2 emissions (% of total fuel combustion) of Tanzania in 2007 and the CO2 emissions (% of total fuel combustion) of Turkmenistan in 2008?
Your response must be concise. -12.35. What is the difference between the CO2 emissions (% of total fuel combustion) in Low & middle income in 2007 and the CO2 emissions (% of total fuel combustion) in Belarus in 2009?
Provide a succinct answer. -0.12. What is the difference between the CO2 emissions (% of total fuel combustion) in Low & middle income in 2007 and the CO2 emissions (% of total fuel combustion) in Tanzania in 2009?
Give a very brief answer. -1.87. What is the difference between the CO2 emissions (% of total fuel combustion) of Low & middle income in 2007 and the CO2 emissions (% of total fuel combustion) of Turkmenistan in 2009?
Offer a terse response. -18.1. What is the difference between the CO2 emissions (% of total fuel combustion) in Belarus in 2007 and the CO2 emissions (% of total fuel combustion) in Tanzania in 2009?
Your response must be concise. -2.02. What is the difference between the CO2 emissions (% of total fuel combustion) of Belarus in 2007 and the CO2 emissions (% of total fuel combustion) of Turkmenistan in 2009?
Your answer should be compact. -18.26. What is the difference between the CO2 emissions (% of total fuel combustion) in Tanzania in 2007 and the CO2 emissions (% of total fuel combustion) in Turkmenistan in 2009?
Ensure brevity in your answer.  -15.22. What is the difference between the CO2 emissions (% of total fuel combustion) of Low & middle income in 2007 and the CO2 emissions (% of total fuel combustion) of Belarus in 2010?
Make the answer very short. -0.35. What is the difference between the CO2 emissions (% of total fuel combustion) of Low & middle income in 2007 and the CO2 emissions (% of total fuel combustion) of Tanzania in 2010?
Your response must be concise. -3.49. What is the difference between the CO2 emissions (% of total fuel combustion) in Low & middle income in 2007 and the CO2 emissions (% of total fuel combustion) in Turkmenistan in 2010?
Your response must be concise. -18.23. What is the difference between the CO2 emissions (% of total fuel combustion) of Belarus in 2007 and the CO2 emissions (% of total fuel combustion) of Tanzania in 2010?
Your answer should be compact. -3.65. What is the difference between the CO2 emissions (% of total fuel combustion) in Belarus in 2007 and the CO2 emissions (% of total fuel combustion) in Turkmenistan in 2010?
Your response must be concise. -18.39. What is the difference between the CO2 emissions (% of total fuel combustion) of Tanzania in 2007 and the CO2 emissions (% of total fuel combustion) of Turkmenistan in 2010?
Offer a very short reply. -15.35. What is the difference between the CO2 emissions (% of total fuel combustion) of Low & middle income in 2008 and the CO2 emissions (% of total fuel combustion) of Belarus in 2009?
Make the answer very short. -0.32. What is the difference between the CO2 emissions (% of total fuel combustion) in Low & middle income in 2008 and the CO2 emissions (% of total fuel combustion) in Tanzania in 2009?
Make the answer very short. -2.06. What is the difference between the CO2 emissions (% of total fuel combustion) in Low & middle income in 2008 and the CO2 emissions (% of total fuel combustion) in Turkmenistan in 2009?
Your answer should be compact. -18.3. What is the difference between the CO2 emissions (% of total fuel combustion) in Belarus in 2008 and the CO2 emissions (% of total fuel combustion) in Tanzania in 2009?
Offer a terse response. -2.21. What is the difference between the CO2 emissions (% of total fuel combustion) in Belarus in 2008 and the CO2 emissions (% of total fuel combustion) in Turkmenistan in 2009?
Ensure brevity in your answer.  -18.45. What is the difference between the CO2 emissions (% of total fuel combustion) of Tanzania in 2008 and the CO2 emissions (% of total fuel combustion) of Turkmenistan in 2009?
Offer a terse response. -14.86. What is the difference between the CO2 emissions (% of total fuel combustion) of Low & middle income in 2008 and the CO2 emissions (% of total fuel combustion) of Belarus in 2010?
Your response must be concise. -0.54. What is the difference between the CO2 emissions (% of total fuel combustion) in Low & middle income in 2008 and the CO2 emissions (% of total fuel combustion) in Tanzania in 2010?
Offer a terse response. -3.68. What is the difference between the CO2 emissions (% of total fuel combustion) in Low & middle income in 2008 and the CO2 emissions (% of total fuel combustion) in Turkmenistan in 2010?
Provide a short and direct response. -18.42. What is the difference between the CO2 emissions (% of total fuel combustion) of Belarus in 2008 and the CO2 emissions (% of total fuel combustion) of Tanzania in 2010?
Keep it short and to the point. -3.83. What is the difference between the CO2 emissions (% of total fuel combustion) in Belarus in 2008 and the CO2 emissions (% of total fuel combustion) in Turkmenistan in 2010?
Keep it short and to the point. -18.57. What is the difference between the CO2 emissions (% of total fuel combustion) in Tanzania in 2008 and the CO2 emissions (% of total fuel combustion) in Turkmenistan in 2010?
Provide a succinct answer. -14.99. What is the difference between the CO2 emissions (% of total fuel combustion) in Low & middle income in 2009 and the CO2 emissions (% of total fuel combustion) in Belarus in 2010?
Keep it short and to the point. -0.82. What is the difference between the CO2 emissions (% of total fuel combustion) of Low & middle income in 2009 and the CO2 emissions (% of total fuel combustion) of Tanzania in 2010?
Your answer should be very brief. -3.96. What is the difference between the CO2 emissions (% of total fuel combustion) in Low & middle income in 2009 and the CO2 emissions (% of total fuel combustion) in Turkmenistan in 2010?
Your answer should be compact. -18.7. What is the difference between the CO2 emissions (% of total fuel combustion) of Belarus in 2009 and the CO2 emissions (% of total fuel combustion) of Tanzania in 2010?
Your response must be concise. -3.36. What is the difference between the CO2 emissions (% of total fuel combustion) of Belarus in 2009 and the CO2 emissions (% of total fuel combustion) of Turkmenistan in 2010?
Your answer should be very brief. -18.1. What is the difference between the CO2 emissions (% of total fuel combustion) in Tanzania in 2009 and the CO2 emissions (% of total fuel combustion) in Turkmenistan in 2010?
Ensure brevity in your answer.  -16.36. What is the average CO2 emissions (% of total fuel combustion) in Low & middle income per year?
Provide a succinct answer. 7.83. What is the average CO2 emissions (% of total fuel combustion) of Belarus per year?
Give a very brief answer. 7.81. What is the average CO2 emissions (% of total fuel combustion) in Tanzania per year?
Offer a terse response. 10.53. What is the average CO2 emissions (% of total fuel combustion) of Turkmenistan per year?
Your response must be concise. 22.77. In the year 2003, what is the difference between the CO2 emissions (% of total fuel combustion) of Low & middle income and CO2 emissions (% of total fuel combustion) of Belarus?
Your answer should be compact. 0.4. In the year 2003, what is the difference between the CO2 emissions (% of total fuel combustion) of Low & middle income and CO2 emissions (% of total fuel combustion) of Tanzania?
Provide a succinct answer. -4.02. In the year 2003, what is the difference between the CO2 emissions (% of total fuel combustion) in Low & middle income and CO2 emissions (% of total fuel combustion) in Turkmenistan?
Your answer should be compact. -11.63. In the year 2003, what is the difference between the CO2 emissions (% of total fuel combustion) of Belarus and CO2 emissions (% of total fuel combustion) of Tanzania?
Your response must be concise. -4.42. In the year 2003, what is the difference between the CO2 emissions (% of total fuel combustion) in Belarus and CO2 emissions (% of total fuel combustion) in Turkmenistan?
Your response must be concise. -12.02. In the year 2003, what is the difference between the CO2 emissions (% of total fuel combustion) of Tanzania and CO2 emissions (% of total fuel combustion) of Turkmenistan?
Keep it short and to the point. -7.6. In the year 2004, what is the difference between the CO2 emissions (% of total fuel combustion) in Low & middle income and CO2 emissions (% of total fuel combustion) in Belarus?
Keep it short and to the point. 0.81. In the year 2004, what is the difference between the CO2 emissions (% of total fuel combustion) in Low & middle income and CO2 emissions (% of total fuel combustion) in Tanzania?
Your answer should be compact. -1.55. In the year 2004, what is the difference between the CO2 emissions (% of total fuel combustion) in Low & middle income and CO2 emissions (% of total fuel combustion) in Turkmenistan?
Give a very brief answer. -12.28. In the year 2004, what is the difference between the CO2 emissions (% of total fuel combustion) of Belarus and CO2 emissions (% of total fuel combustion) of Tanzania?
Offer a terse response. -2.36. In the year 2004, what is the difference between the CO2 emissions (% of total fuel combustion) in Belarus and CO2 emissions (% of total fuel combustion) in Turkmenistan?
Your response must be concise. -13.1. In the year 2004, what is the difference between the CO2 emissions (% of total fuel combustion) in Tanzania and CO2 emissions (% of total fuel combustion) in Turkmenistan?
Your answer should be compact. -10.73. In the year 2005, what is the difference between the CO2 emissions (% of total fuel combustion) in Low & middle income and CO2 emissions (% of total fuel combustion) in Belarus?
Your answer should be very brief. 0.09. In the year 2005, what is the difference between the CO2 emissions (% of total fuel combustion) of Low & middle income and CO2 emissions (% of total fuel combustion) of Tanzania?
Your response must be concise. -1.55. In the year 2005, what is the difference between the CO2 emissions (% of total fuel combustion) of Low & middle income and CO2 emissions (% of total fuel combustion) of Turkmenistan?
Make the answer very short. -12.17. In the year 2005, what is the difference between the CO2 emissions (% of total fuel combustion) in Belarus and CO2 emissions (% of total fuel combustion) in Tanzania?
Provide a succinct answer. -1.63. In the year 2005, what is the difference between the CO2 emissions (% of total fuel combustion) of Belarus and CO2 emissions (% of total fuel combustion) of Turkmenistan?
Offer a terse response. -12.25. In the year 2005, what is the difference between the CO2 emissions (% of total fuel combustion) of Tanzania and CO2 emissions (% of total fuel combustion) of Turkmenistan?
Provide a short and direct response. -10.62. In the year 2006, what is the difference between the CO2 emissions (% of total fuel combustion) in Low & middle income and CO2 emissions (% of total fuel combustion) in Belarus?
Your response must be concise. 0.33. In the year 2006, what is the difference between the CO2 emissions (% of total fuel combustion) in Low & middle income and CO2 emissions (% of total fuel combustion) in Tanzania?
Give a very brief answer. -1.57. In the year 2006, what is the difference between the CO2 emissions (% of total fuel combustion) in Low & middle income and CO2 emissions (% of total fuel combustion) in Turkmenistan?
Give a very brief answer. -13.14. In the year 2006, what is the difference between the CO2 emissions (% of total fuel combustion) of Belarus and CO2 emissions (% of total fuel combustion) of Tanzania?
Give a very brief answer. -1.9. In the year 2006, what is the difference between the CO2 emissions (% of total fuel combustion) in Belarus and CO2 emissions (% of total fuel combustion) in Turkmenistan?
Give a very brief answer. -13.46. In the year 2006, what is the difference between the CO2 emissions (% of total fuel combustion) of Tanzania and CO2 emissions (% of total fuel combustion) of Turkmenistan?
Offer a very short reply. -11.57. In the year 2007, what is the difference between the CO2 emissions (% of total fuel combustion) in Low & middle income and CO2 emissions (% of total fuel combustion) in Belarus?
Your answer should be compact. 0.16. In the year 2007, what is the difference between the CO2 emissions (% of total fuel combustion) in Low & middle income and CO2 emissions (% of total fuel combustion) in Tanzania?
Ensure brevity in your answer.  -2.88. In the year 2007, what is the difference between the CO2 emissions (% of total fuel combustion) of Low & middle income and CO2 emissions (% of total fuel combustion) of Turkmenistan?
Offer a very short reply. -17.28. In the year 2007, what is the difference between the CO2 emissions (% of total fuel combustion) of Belarus and CO2 emissions (% of total fuel combustion) of Tanzania?
Offer a very short reply. -3.04. In the year 2007, what is the difference between the CO2 emissions (% of total fuel combustion) of Belarus and CO2 emissions (% of total fuel combustion) of Turkmenistan?
Provide a short and direct response. -17.44. In the year 2007, what is the difference between the CO2 emissions (% of total fuel combustion) of Tanzania and CO2 emissions (% of total fuel combustion) of Turkmenistan?
Offer a terse response. -14.4. In the year 2008, what is the difference between the CO2 emissions (% of total fuel combustion) in Low & middle income and CO2 emissions (% of total fuel combustion) in Belarus?
Ensure brevity in your answer.  0.15. In the year 2008, what is the difference between the CO2 emissions (% of total fuel combustion) of Low & middle income and CO2 emissions (% of total fuel combustion) of Tanzania?
Offer a terse response. -3.43. In the year 2008, what is the difference between the CO2 emissions (% of total fuel combustion) in Low & middle income and CO2 emissions (% of total fuel combustion) in Turkmenistan?
Your answer should be very brief. -15.42. In the year 2008, what is the difference between the CO2 emissions (% of total fuel combustion) in Belarus and CO2 emissions (% of total fuel combustion) in Tanzania?
Provide a short and direct response. -3.59. In the year 2008, what is the difference between the CO2 emissions (% of total fuel combustion) in Belarus and CO2 emissions (% of total fuel combustion) in Turkmenistan?
Your answer should be very brief. -15.57. In the year 2008, what is the difference between the CO2 emissions (% of total fuel combustion) in Tanzania and CO2 emissions (% of total fuel combustion) in Turkmenistan?
Offer a very short reply. -11.98. In the year 2009, what is the difference between the CO2 emissions (% of total fuel combustion) of Low & middle income and CO2 emissions (% of total fuel combustion) of Belarus?
Make the answer very short. -0.6. In the year 2009, what is the difference between the CO2 emissions (% of total fuel combustion) in Low & middle income and CO2 emissions (% of total fuel combustion) in Tanzania?
Provide a succinct answer. -2.34. In the year 2009, what is the difference between the CO2 emissions (% of total fuel combustion) of Low & middle income and CO2 emissions (% of total fuel combustion) of Turkmenistan?
Your answer should be very brief. -18.57. In the year 2009, what is the difference between the CO2 emissions (% of total fuel combustion) in Belarus and CO2 emissions (% of total fuel combustion) in Tanzania?
Make the answer very short. -1.74. In the year 2009, what is the difference between the CO2 emissions (% of total fuel combustion) in Belarus and CO2 emissions (% of total fuel combustion) in Turkmenistan?
Your answer should be compact. -17.98. In the year 2009, what is the difference between the CO2 emissions (% of total fuel combustion) of Tanzania and CO2 emissions (% of total fuel combustion) of Turkmenistan?
Make the answer very short. -16.24. In the year 2010, what is the difference between the CO2 emissions (% of total fuel combustion) of Low & middle income and CO2 emissions (% of total fuel combustion) of Belarus?
Make the answer very short. -1.14. In the year 2010, what is the difference between the CO2 emissions (% of total fuel combustion) in Low & middle income and CO2 emissions (% of total fuel combustion) in Tanzania?
Provide a short and direct response. -4.28. In the year 2010, what is the difference between the CO2 emissions (% of total fuel combustion) of Low & middle income and CO2 emissions (% of total fuel combustion) of Turkmenistan?
Your answer should be compact. -19.03. In the year 2010, what is the difference between the CO2 emissions (% of total fuel combustion) of Belarus and CO2 emissions (% of total fuel combustion) of Tanzania?
Offer a terse response. -3.14. In the year 2010, what is the difference between the CO2 emissions (% of total fuel combustion) of Belarus and CO2 emissions (% of total fuel combustion) of Turkmenistan?
Your answer should be very brief. -17.88. In the year 2010, what is the difference between the CO2 emissions (% of total fuel combustion) in Tanzania and CO2 emissions (% of total fuel combustion) in Turkmenistan?
Your answer should be very brief. -14.74. What is the ratio of the CO2 emissions (% of total fuel combustion) of Low & middle income in 2003 to that in 2004?
Offer a terse response. 1.02. What is the ratio of the CO2 emissions (% of total fuel combustion) of Belarus in 2003 to that in 2004?
Your answer should be compact. 1.07. What is the ratio of the CO2 emissions (% of total fuel combustion) of Tanzania in 2003 to that in 2004?
Keep it short and to the point. 1.26. What is the ratio of the CO2 emissions (% of total fuel combustion) of Turkmenistan in 2003 to that in 2004?
Offer a very short reply. 0.98. What is the ratio of the CO2 emissions (% of total fuel combustion) of Low & middle income in 2003 to that in 2005?
Offer a very short reply. 1.07. What is the ratio of the CO2 emissions (% of total fuel combustion) of Belarus in 2003 to that in 2005?
Offer a very short reply. 1.03. What is the ratio of the CO2 emissions (% of total fuel combustion) in Tanzania in 2003 to that in 2005?
Your answer should be compact. 1.31. What is the ratio of the CO2 emissions (% of total fuel combustion) in Turkmenistan in 2003 to that in 2005?
Provide a succinct answer. 1. What is the ratio of the CO2 emissions (% of total fuel combustion) of Low & middle income in 2003 to that in 2006?
Give a very brief answer. 1.09. What is the ratio of the CO2 emissions (% of total fuel combustion) in Belarus in 2003 to that in 2006?
Keep it short and to the point. 1.08. What is the ratio of the CO2 emissions (% of total fuel combustion) in Tanzania in 2003 to that in 2006?
Keep it short and to the point. 1.33. What is the ratio of the CO2 emissions (% of total fuel combustion) in Low & middle income in 2003 to that in 2007?
Your answer should be very brief. 1.11. What is the ratio of the CO2 emissions (% of total fuel combustion) of Belarus in 2003 to that in 2007?
Give a very brief answer. 1.08. What is the ratio of the CO2 emissions (% of total fuel combustion) in Tanzania in 2003 to that in 2007?
Your answer should be compact. 1.19. What is the ratio of the CO2 emissions (% of total fuel combustion) in Turkmenistan in 2003 to that in 2007?
Keep it short and to the point. 0.81. What is the ratio of the CO2 emissions (% of total fuel combustion) of Low & middle income in 2003 to that in 2008?
Your response must be concise. 1.14. What is the ratio of the CO2 emissions (% of total fuel combustion) of Belarus in 2003 to that in 2008?
Your response must be concise. 1.11. What is the ratio of the CO2 emissions (% of total fuel combustion) in Tanzania in 2003 to that in 2008?
Give a very brief answer. 1.15. What is the ratio of the CO2 emissions (% of total fuel combustion) of Turkmenistan in 2003 to that in 2008?
Your response must be concise. 0.88. What is the ratio of the CO2 emissions (% of total fuel combustion) in Low & middle income in 2003 to that in 2009?
Your answer should be very brief. 1.19. What is the ratio of the CO2 emissions (% of total fuel combustion) of Belarus in 2003 to that in 2009?
Your response must be concise. 1.05. What is the ratio of the CO2 emissions (% of total fuel combustion) of Tanzania in 2003 to that in 2009?
Provide a succinct answer. 1.32. What is the ratio of the CO2 emissions (% of total fuel combustion) of Turkmenistan in 2003 to that in 2009?
Your response must be concise. 0.78. What is the ratio of the CO2 emissions (% of total fuel combustion) in Low & middle income in 2003 to that in 2010?
Offer a very short reply. 1.24. What is the ratio of the CO2 emissions (% of total fuel combustion) of Belarus in 2003 to that in 2010?
Your response must be concise. 1.02. What is the ratio of the CO2 emissions (% of total fuel combustion) of Tanzania in 2003 to that in 2010?
Your answer should be very brief. 1.13. What is the ratio of the CO2 emissions (% of total fuel combustion) of Turkmenistan in 2003 to that in 2010?
Ensure brevity in your answer.  0.78. What is the ratio of the CO2 emissions (% of total fuel combustion) of Low & middle income in 2004 to that in 2005?
Offer a very short reply. 1.05. What is the ratio of the CO2 emissions (% of total fuel combustion) of Belarus in 2004 to that in 2005?
Offer a very short reply. 0.96. What is the ratio of the CO2 emissions (% of total fuel combustion) of Tanzania in 2004 to that in 2005?
Your response must be concise. 1.04. What is the ratio of the CO2 emissions (% of total fuel combustion) in Turkmenistan in 2004 to that in 2005?
Offer a very short reply. 1.02. What is the ratio of the CO2 emissions (% of total fuel combustion) of Low & middle income in 2004 to that in 2006?
Your answer should be very brief. 1.07. What is the ratio of the CO2 emissions (% of total fuel combustion) in Belarus in 2004 to that in 2006?
Give a very brief answer. 1.01. What is the ratio of the CO2 emissions (% of total fuel combustion) of Tanzania in 2004 to that in 2006?
Make the answer very short. 1.06. What is the ratio of the CO2 emissions (% of total fuel combustion) of Turkmenistan in 2004 to that in 2006?
Your answer should be compact. 0.99. What is the ratio of the CO2 emissions (% of total fuel combustion) of Low & middle income in 2004 to that in 2007?
Your answer should be compact. 1.09. What is the ratio of the CO2 emissions (% of total fuel combustion) in Belarus in 2004 to that in 2007?
Provide a short and direct response. 1.01. What is the ratio of the CO2 emissions (% of total fuel combustion) of Tanzania in 2004 to that in 2007?
Provide a succinct answer. 0.94. What is the ratio of the CO2 emissions (% of total fuel combustion) of Turkmenistan in 2004 to that in 2007?
Provide a short and direct response. 0.83. What is the ratio of the CO2 emissions (% of total fuel combustion) of Low & middle income in 2004 to that in 2008?
Ensure brevity in your answer.  1.12. What is the ratio of the CO2 emissions (% of total fuel combustion) in Belarus in 2004 to that in 2008?
Offer a very short reply. 1.03. What is the ratio of the CO2 emissions (% of total fuel combustion) in Tanzania in 2004 to that in 2008?
Offer a very short reply. 0.91. What is the ratio of the CO2 emissions (% of total fuel combustion) of Turkmenistan in 2004 to that in 2008?
Ensure brevity in your answer.  0.9. What is the ratio of the CO2 emissions (% of total fuel combustion) of Low & middle income in 2004 to that in 2009?
Ensure brevity in your answer.  1.16. What is the ratio of the CO2 emissions (% of total fuel combustion) in Belarus in 2004 to that in 2009?
Offer a terse response. 0.97. What is the ratio of the CO2 emissions (% of total fuel combustion) of Tanzania in 2004 to that in 2009?
Your response must be concise. 1.04. What is the ratio of the CO2 emissions (% of total fuel combustion) of Turkmenistan in 2004 to that in 2009?
Offer a terse response. 0.8. What is the ratio of the CO2 emissions (% of total fuel combustion) in Low & middle income in 2004 to that in 2010?
Make the answer very short. 1.22. What is the ratio of the CO2 emissions (% of total fuel combustion) in Belarus in 2004 to that in 2010?
Make the answer very short. 0.95. What is the ratio of the CO2 emissions (% of total fuel combustion) of Tanzania in 2004 to that in 2010?
Provide a short and direct response. 0.89. What is the ratio of the CO2 emissions (% of total fuel combustion) of Turkmenistan in 2004 to that in 2010?
Your answer should be very brief. 0.8. What is the ratio of the CO2 emissions (% of total fuel combustion) in Low & middle income in 2005 to that in 2006?
Provide a short and direct response. 1.02. What is the ratio of the CO2 emissions (% of total fuel combustion) in Belarus in 2005 to that in 2006?
Provide a short and direct response. 1.06. What is the ratio of the CO2 emissions (% of total fuel combustion) in Tanzania in 2005 to that in 2006?
Your answer should be compact. 1.02. What is the ratio of the CO2 emissions (% of total fuel combustion) in Turkmenistan in 2005 to that in 2006?
Your response must be concise. 0.96. What is the ratio of the CO2 emissions (% of total fuel combustion) in Low & middle income in 2005 to that in 2007?
Offer a very short reply. 1.04. What is the ratio of the CO2 emissions (% of total fuel combustion) of Belarus in 2005 to that in 2007?
Provide a succinct answer. 1.06. What is the ratio of the CO2 emissions (% of total fuel combustion) of Tanzania in 2005 to that in 2007?
Your response must be concise. 0.91. What is the ratio of the CO2 emissions (% of total fuel combustion) in Turkmenistan in 2005 to that in 2007?
Make the answer very short. 0.81. What is the ratio of the CO2 emissions (% of total fuel combustion) in Low & middle income in 2005 to that in 2008?
Your answer should be very brief. 1.07. What is the ratio of the CO2 emissions (% of total fuel combustion) of Belarus in 2005 to that in 2008?
Keep it short and to the point. 1.08. What is the ratio of the CO2 emissions (% of total fuel combustion) of Tanzania in 2005 to that in 2008?
Your answer should be very brief. 0.88. What is the ratio of the CO2 emissions (% of total fuel combustion) in Turkmenistan in 2005 to that in 2008?
Ensure brevity in your answer.  0.88. What is the ratio of the CO2 emissions (% of total fuel combustion) of Low & middle income in 2005 to that in 2009?
Your response must be concise. 1.11. What is the ratio of the CO2 emissions (% of total fuel combustion) in Belarus in 2005 to that in 2009?
Keep it short and to the point. 1.02. What is the ratio of the CO2 emissions (% of total fuel combustion) of Tanzania in 2005 to that in 2009?
Keep it short and to the point. 1. What is the ratio of the CO2 emissions (% of total fuel combustion) of Turkmenistan in 2005 to that in 2009?
Keep it short and to the point. 0.78. What is the ratio of the CO2 emissions (% of total fuel combustion) in Low & middle income in 2005 to that in 2010?
Offer a very short reply. 1.16. What is the ratio of the CO2 emissions (% of total fuel combustion) in Belarus in 2005 to that in 2010?
Provide a short and direct response. 0.99. What is the ratio of the CO2 emissions (% of total fuel combustion) in Tanzania in 2005 to that in 2010?
Your answer should be compact. 0.86. What is the ratio of the CO2 emissions (% of total fuel combustion) in Turkmenistan in 2005 to that in 2010?
Ensure brevity in your answer.  0.78. What is the ratio of the CO2 emissions (% of total fuel combustion) in Low & middle income in 2006 to that in 2007?
Provide a succinct answer. 1.02. What is the ratio of the CO2 emissions (% of total fuel combustion) of Tanzania in 2006 to that in 2007?
Ensure brevity in your answer.  0.89. What is the ratio of the CO2 emissions (% of total fuel combustion) in Turkmenistan in 2006 to that in 2007?
Your answer should be very brief. 0.84. What is the ratio of the CO2 emissions (% of total fuel combustion) of Low & middle income in 2006 to that in 2008?
Keep it short and to the point. 1.05. What is the ratio of the CO2 emissions (% of total fuel combustion) in Belarus in 2006 to that in 2008?
Offer a terse response. 1.03. What is the ratio of the CO2 emissions (% of total fuel combustion) of Tanzania in 2006 to that in 2008?
Provide a succinct answer. 0.86. What is the ratio of the CO2 emissions (% of total fuel combustion) in Turkmenistan in 2006 to that in 2008?
Make the answer very short. 0.92. What is the ratio of the CO2 emissions (% of total fuel combustion) in Low & middle income in 2006 to that in 2009?
Provide a short and direct response. 1.09. What is the ratio of the CO2 emissions (% of total fuel combustion) in Belarus in 2006 to that in 2009?
Give a very brief answer. 0.96. What is the ratio of the CO2 emissions (% of total fuel combustion) in Tanzania in 2006 to that in 2009?
Keep it short and to the point. 0.99. What is the ratio of the CO2 emissions (% of total fuel combustion) in Turkmenistan in 2006 to that in 2009?
Your response must be concise. 0.81. What is the ratio of the CO2 emissions (% of total fuel combustion) of Low & middle income in 2006 to that in 2010?
Give a very brief answer. 1.14. What is the ratio of the CO2 emissions (% of total fuel combustion) of Belarus in 2006 to that in 2010?
Make the answer very short. 0.94. What is the ratio of the CO2 emissions (% of total fuel combustion) in Tanzania in 2006 to that in 2010?
Keep it short and to the point. 0.84. What is the ratio of the CO2 emissions (% of total fuel combustion) in Turkmenistan in 2006 to that in 2010?
Ensure brevity in your answer.  0.81. What is the ratio of the CO2 emissions (% of total fuel combustion) in Low & middle income in 2007 to that in 2008?
Give a very brief answer. 1.03. What is the ratio of the CO2 emissions (% of total fuel combustion) of Belarus in 2007 to that in 2008?
Provide a short and direct response. 1.03. What is the ratio of the CO2 emissions (% of total fuel combustion) in Turkmenistan in 2007 to that in 2008?
Your answer should be compact. 1.09. What is the ratio of the CO2 emissions (% of total fuel combustion) in Low & middle income in 2007 to that in 2009?
Your response must be concise. 1.06. What is the ratio of the CO2 emissions (% of total fuel combustion) in Belarus in 2007 to that in 2009?
Make the answer very short. 0.96. What is the ratio of the CO2 emissions (% of total fuel combustion) in Tanzania in 2007 to that in 2009?
Ensure brevity in your answer.  1.11. What is the ratio of the CO2 emissions (% of total fuel combustion) in Turkmenistan in 2007 to that in 2009?
Provide a short and direct response. 0.97. What is the ratio of the CO2 emissions (% of total fuel combustion) of Low & middle income in 2007 to that in 2010?
Your answer should be compact. 1.11. What is the ratio of the CO2 emissions (% of total fuel combustion) in Belarus in 2007 to that in 2010?
Ensure brevity in your answer.  0.94. What is the ratio of the CO2 emissions (% of total fuel combustion) of Tanzania in 2007 to that in 2010?
Keep it short and to the point. 0.95. What is the ratio of the CO2 emissions (% of total fuel combustion) of Turkmenistan in 2007 to that in 2010?
Give a very brief answer. 0.96. What is the ratio of the CO2 emissions (% of total fuel combustion) in Low & middle income in 2008 to that in 2009?
Make the answer very short. 1.04. What is the ratio of the CO2 emissions (% of total fuel combustion) in Belarus in 2008 to that in 2009?
Offer a terse response. 0.94. What is the ratio of the CO2 emissions (% of total fuel combustion) in Tanzania in 2008 to that in 2009?
Offer a terse response. 1.14. What is the ratio of the CO2 emissions (% of total fuel combustion) in Turkmenistan in 2008 to that in 2009?
Provide a short and direct response. 0.89. What is the ratio of the CO2 emissions (% of total fuel combustion) of Low & middle income in 2008 to that in 2010?
Keep it short and to the point. 1.09. What is the ratio of the CO2 emissions (% of total fuel combustion) in Belarus in 2008 to that in 2010?
Keep it short and to the point. 0.91. What is the ratio of the CO2 emissions (% of total fuel combustion) of Tanzania in 2008 to that in 2010?
Offer a terse response. 0.98. What is the ratio of the CO2 emissions (% of total fuel combustion) of Turkmenistan in 2008 to that in 2010?
Keep it short and to the point. 0.88. What is the ratio of the CO2 emissions (% of total fuel combustion) in Low & middle income in 2009 to that in 2010?
Make the answer very short. 1.05. What is the ratio of the CO2 emissions (% of total fuel combustion) of Belarus in 2009 to that in 2010?
Offer a terse response. 0.97. What is the ratio of the CO2 emissions (% of total fuel combustion) in Tanzania in 2009 to that in 2010?
Make the answer very short. 0.86. What is the ratio of the CO2 emissions (% of total fuel combustion) in Turkmenistan in 2009 to that in 2010?
Your response must be concise. 1. What is the difference between the highest and the second highest CO2 emissions (% of total fuel combustion) in Low & middle income?
Your answer should be compact. 0.15. What is the difference between the highest and the second highest CO2 emissions (% of total fuel combustion) in Belarus?
Provide a short and direct response. 0.13. What is the difference between the highest and the second highest CO2 emissions (% of total fuel combustion) of Tanzania?
Offer a very short reply. 1.41. What is the difference between the highest and the second highest CO2 emissions (% of total fuel combustion) of Turkmenistan?
Ensure brevity in your answer.  0.13. What is the difference between the highest and the lowest CO2 emissions (% of total fuel combustion) in Low & middle income?
Make the answer very short. 1.68. What is the difference between the highest and the lowest CO2 emissions (% of total fuel combustion) in Belarus?
Provide a succinct answer. 0.83. What is the difference between the highest and the lowest CO2 emissions (% of total fuel combustion) of Tanzania?
Ensure brevity in your answer.  3.16. What is the difference between the highest and the lowest CO2 emissions (% of total fuel combustion) in Turkmenistan?
Your answer should be compact. 5.72. 